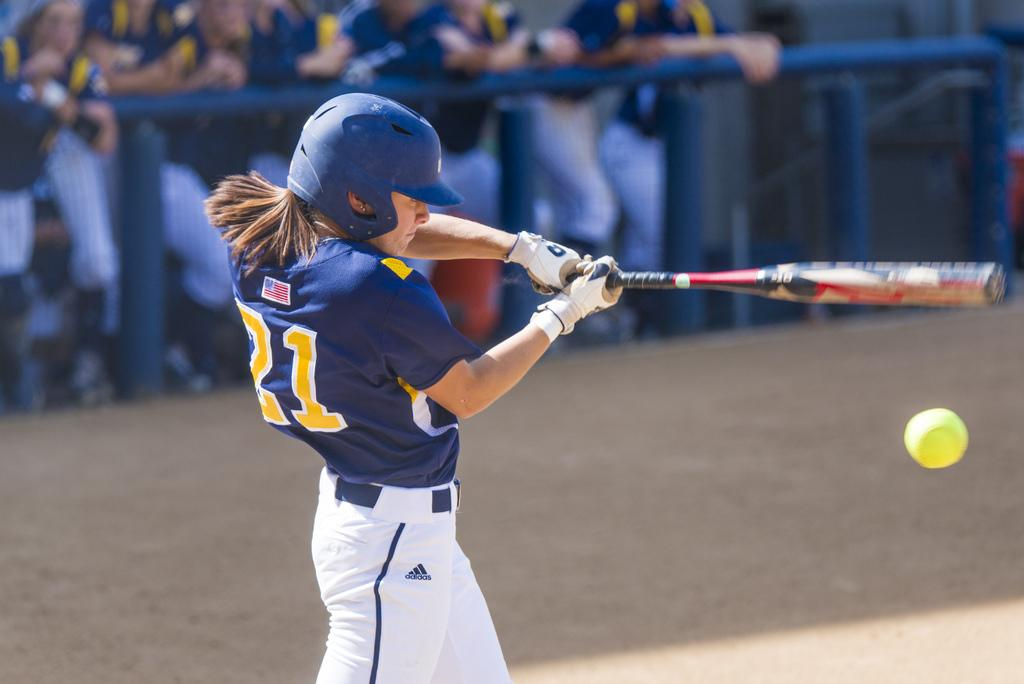What is the main subject of the image? The main subject of the image is a person standing on the ground. What is the person doing in the image? The person is about to hit a ball. What can be seen in the background of the image? There are people holding a metal fence in the background of the image. What type of haircut does the spy have in the image? There is no spy present in the image, and therefore no haircut can be observed. Can you tell me how many bananas are on the ground in the image? There are no bananas present in the image; the main subject is a person standing on the ground and about to hit a ball. 